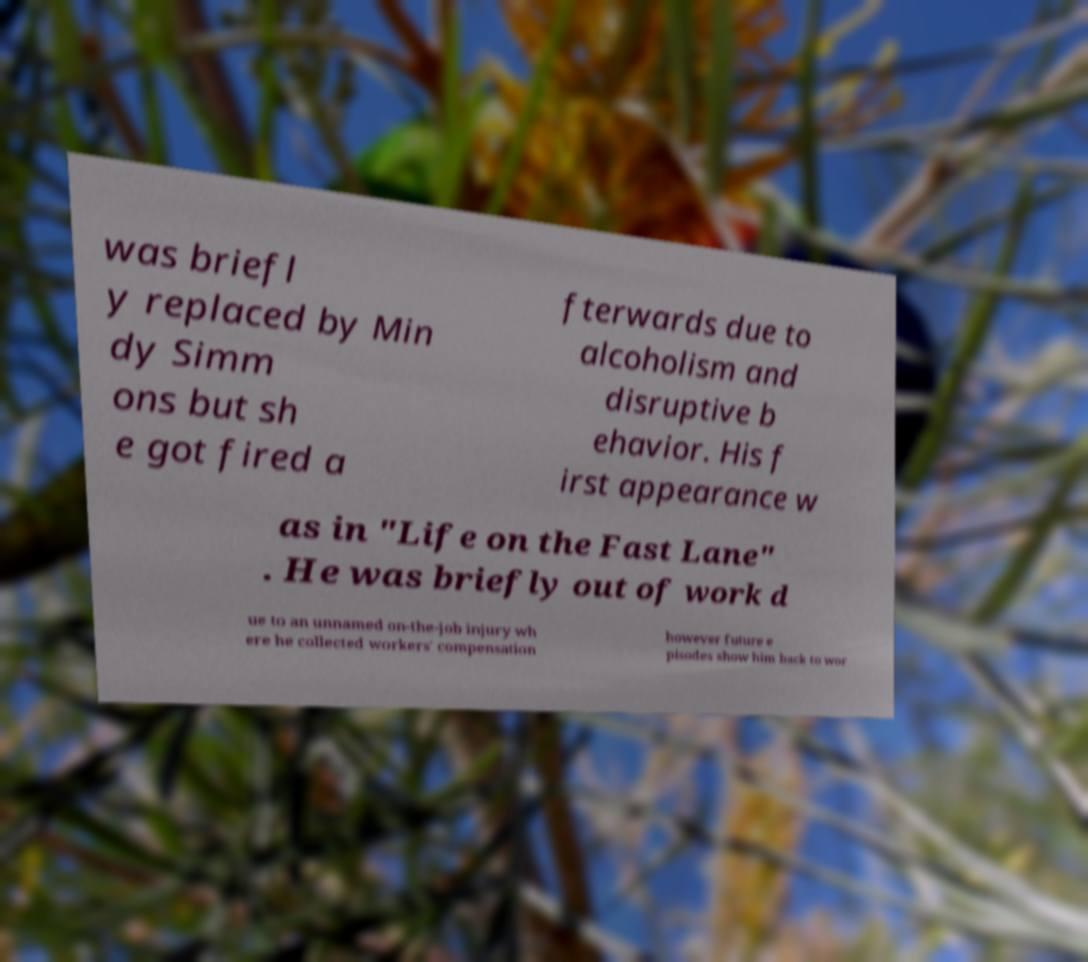Can you accurately transcribe the text from the provided image for me? was briefl y replaced by Min dy Simm ons but sh e got fired a fterwards due to alcoholism and disruptive b ehavior. His f irst appearance w as in "Life on the Fast Lane" . He was briefly out of work d ue to an unnamed on-the-job injury wh ere he collected workers' compensation however future e pisodes show him back to wor 